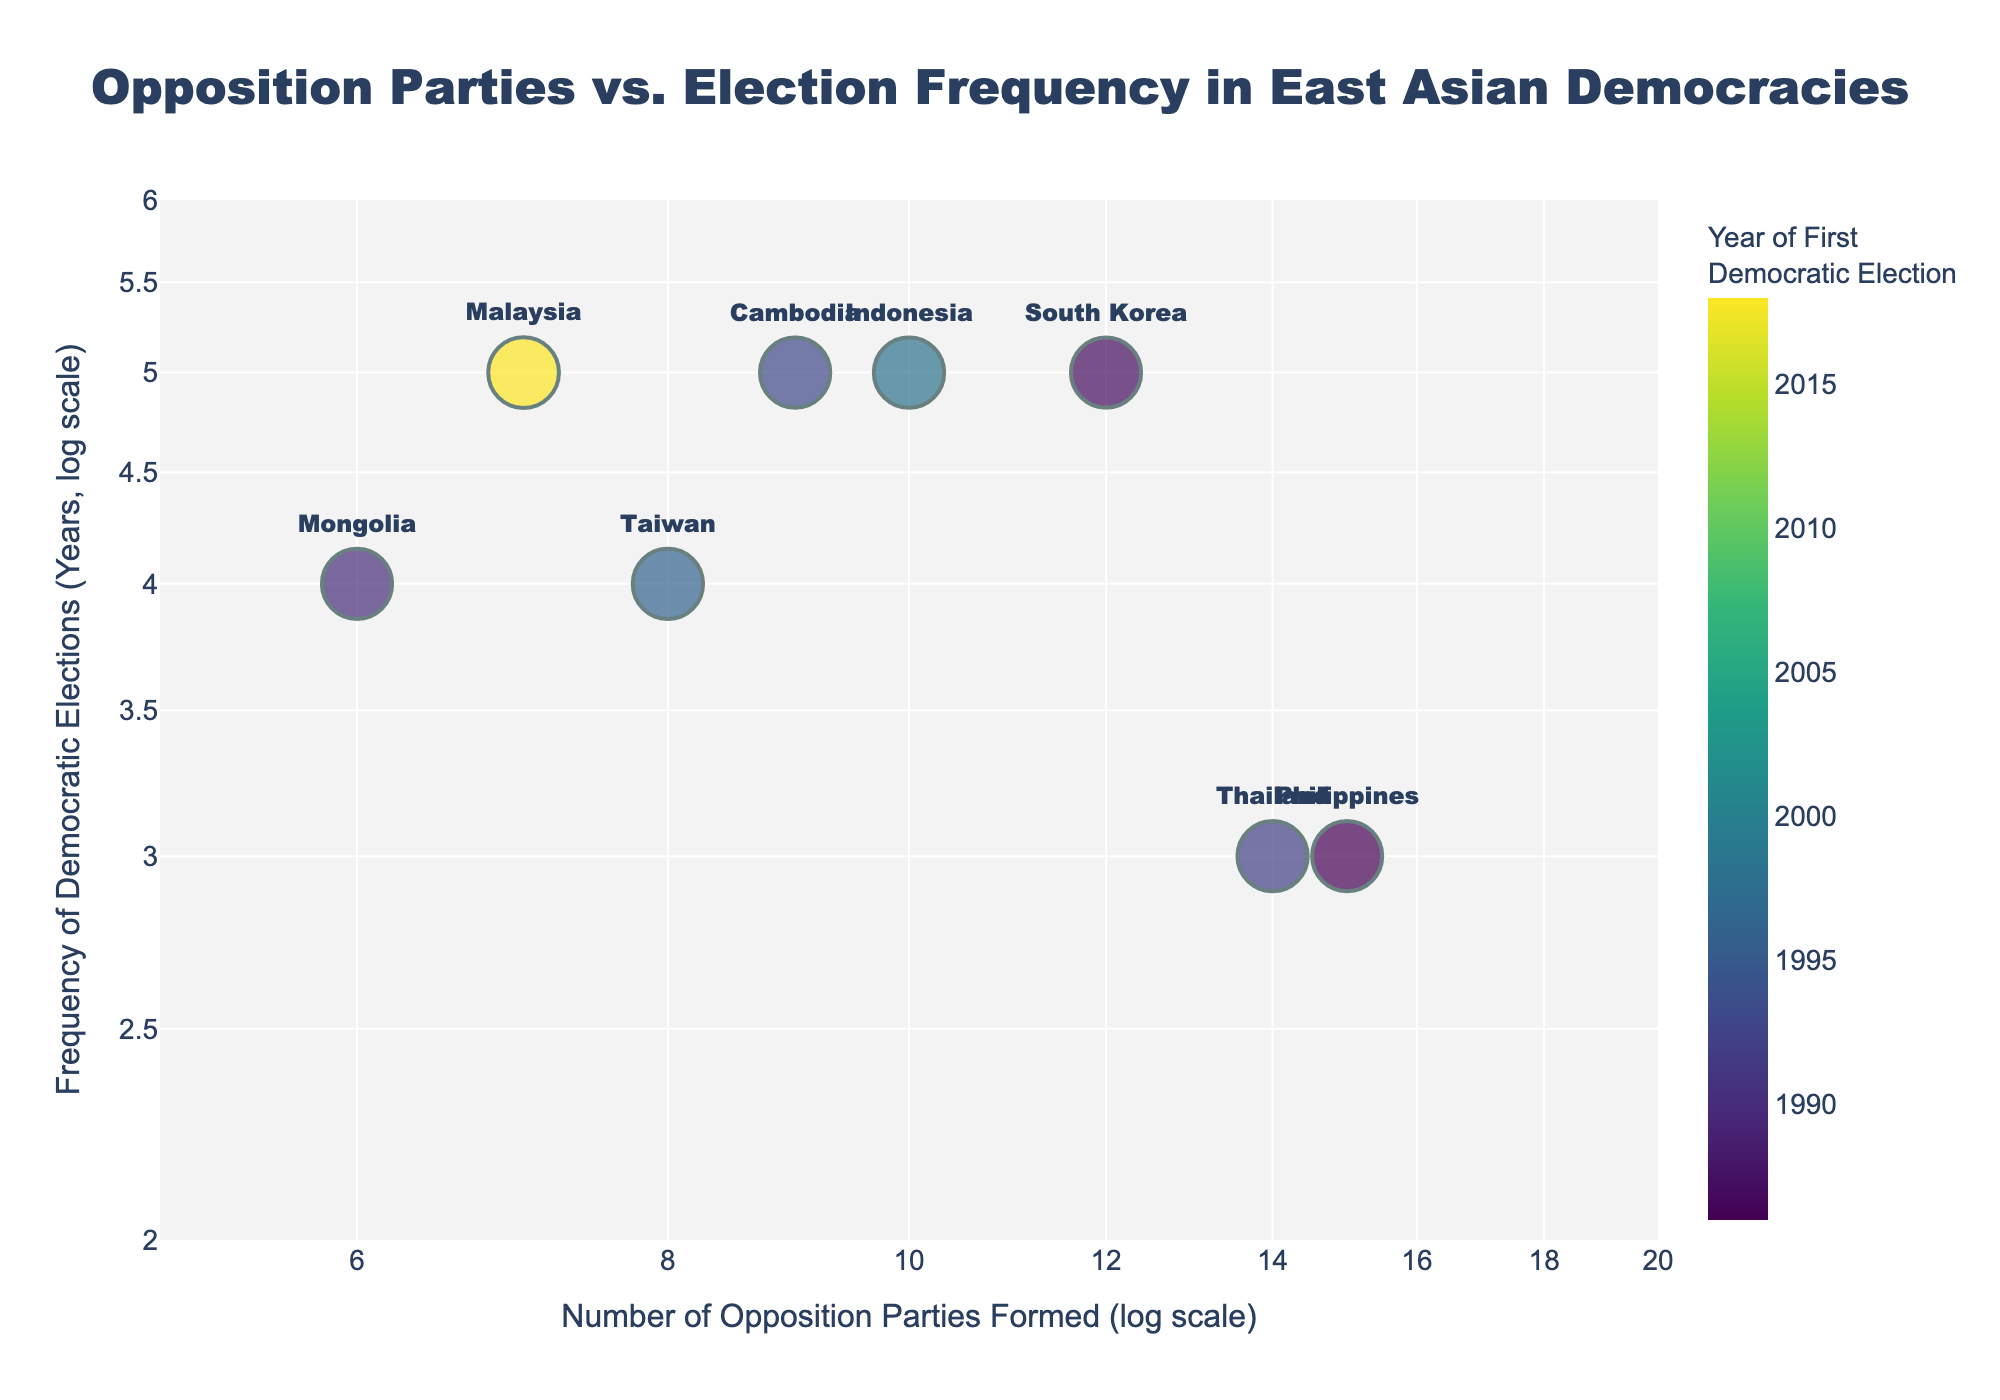What's the title of the figure? The title is located at the top of the figure and provides an overview of what the plot is about. In this case, it mentions the relationship between opposition parties and election frequency in East Asian democracies.
Answer: Opposition Parties vs. Election Frequency in East Asian Democracies What's the axis title for the x-axis? The x-axis title is below the horizontal axis and it describes what the data points along the x-axis represent. The figure uses a log scale for the number of opposition parties formed.
Answer: Number of Opposition Parties Formed (log scale) Which country has the highest number of opposition parties formed? Look for the data point that is furthest to the right on the x-axis, which represents the highest value of opposition parties formed.
Answer: Philippines Which two countries have the same election frequency of 5 years? Find the data points that are aligned horizontally at the value of 5 years on the y-axis. The text labels next to the points will indicate the countries.
Answer: South Korea and Cambodia What is the frequency of democratic elections in Taiwan? Locate the data point labeled Taiwan and refer to its position on the y-axis, which indicates election frequency in years.
Answer: 4 years How many countries held their first democratic election after 1995? Count the data points that have a color indicating a year after 1995. This information is derived from the color scale that represents the Year of First Democratic Election.
Answer: Three countries (Taiwan, Indonesia, and Malaysia) Which country has the smallest size marker and what does it represent? Identify the smallest circle on the plot. The marker size represents the Year of First Democratic Election, so the smallest size corresponds to the earliest year.
Answer: Philippines (1986) Between South Korea and Thailand, which has more opposition parties formed? Compare the x-axis positions of South Korea and Thailand. The country further to the right has the higher number of opposition parties formed.
Answer: Thailand What is the mean number of opposition parties formed across all countries? Sum the number of opposition parties for each country and divide by the total number of countries. The numbers are 12, 8, 6, 15, 10, 14, 9, and 7. Sum is 81, divided by 8 countries.
Answer: 10.125 On average, how frequently are democratic elections held across these countries? Sum the frequency of elections for each country and divide by the total number of countries. The numbers are 5, 4, 4, 3, 5, 3, 5, and 5. Sum is 34, divided by 8 countries.
Answer: 4.25 years 